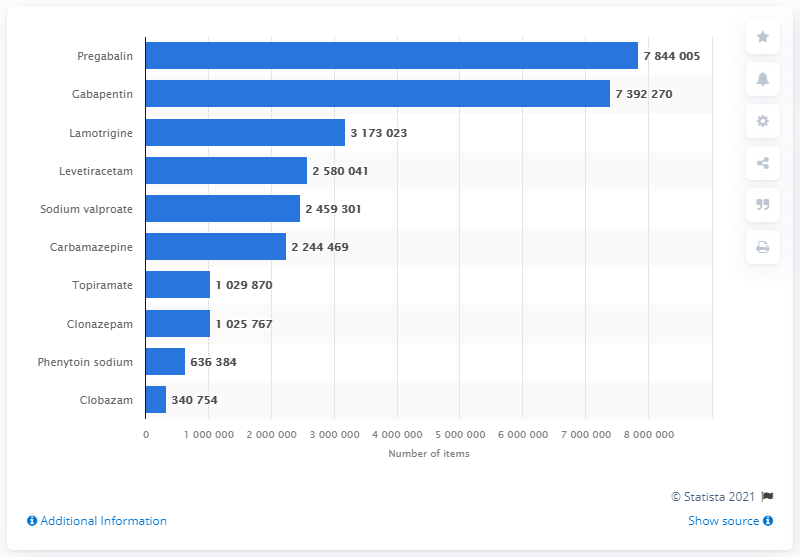Identify some key points in this picture. In England in 2020, a total of 784,4005 gabapentin items were dispensed. 